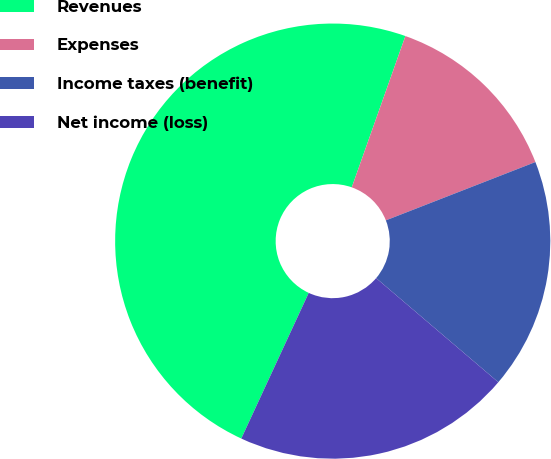<chart> <loc_0><loc_0><loc_500><loc_500><pie_chart><fcel>Revenues<fcel>Expenses<fcel>Income taxes (benefit)<fcel>Net income (loss)<nl><fcel>48.52%<fcel>13.66%<fcel>17.15%<fcel>20.67%<nl></chart> 